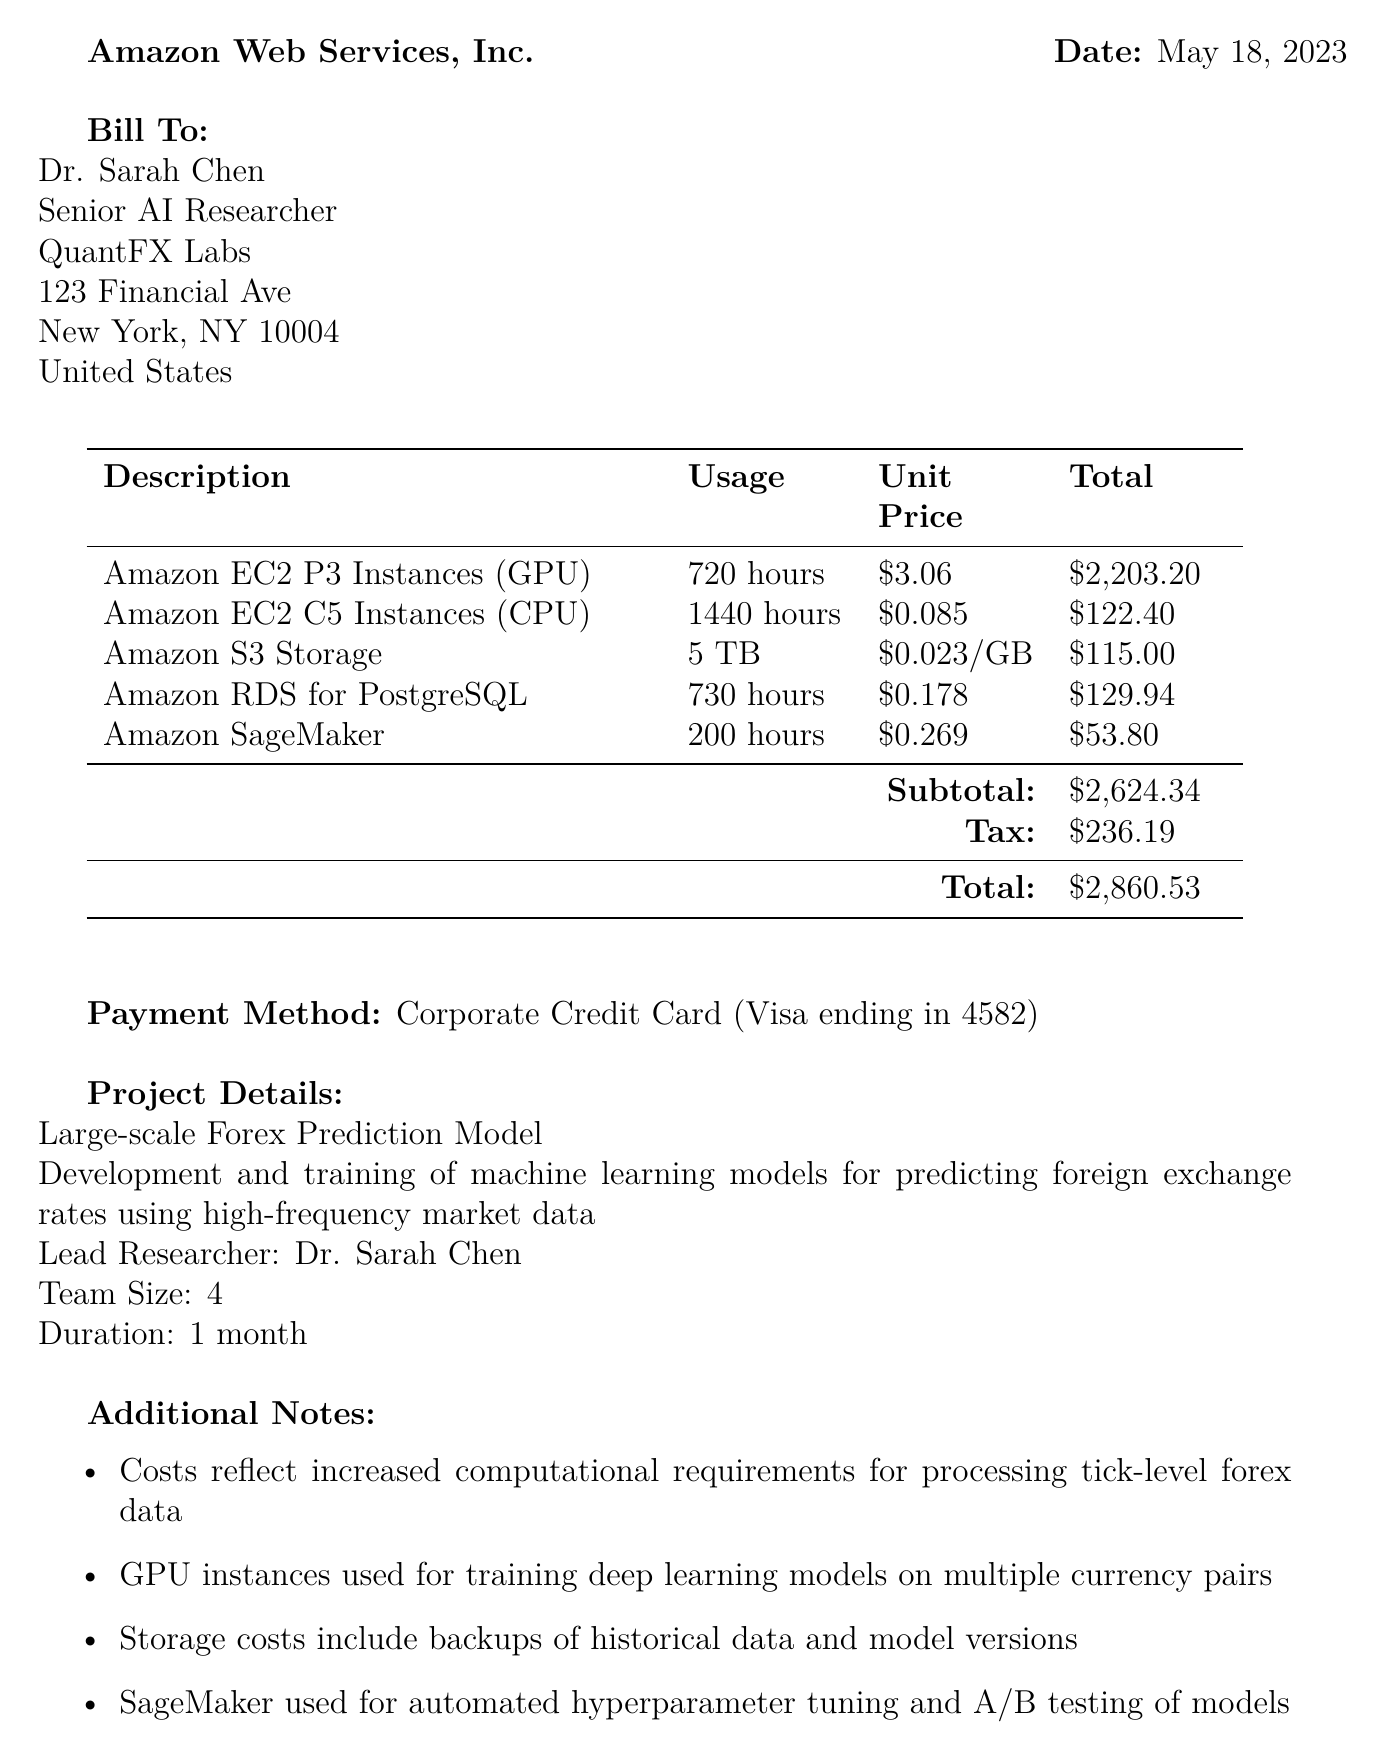what is the receipt number? The receipt number is mentioned at the top of the document and is used to identify the transaction.
Answer: INV-ML20230518-001 who is the lead researcher for the project? The document provides the name of the lead researcher in the project details section.
Answer: Dr. Sarah Chen what is the total amount due? The total amount due is calculated after summing up the subtotal and tax in the financial details of the document.
Answer: $2,860.53 how many hours were used for GPU instances? The usage for GPU instances is specified in the service breakdown of the receipt.
Answer: 720 hours which cloud service was used for storage? The document lists various services used, with a specific mention of the storage solution in the services section.
Answer: Amazon S3 Storage how many team members are involved in the project? The number of team members is directly mentioned in the project details section of the document.
Answer: 4 what is the primary purpose of Amazon SageMaker in this context? The document describes the use of Amazon SageMaker as part of the project details, clarifying its function.
Answer: Managed machine learning platform what is the tax amount charged? The tax amount is explicitly stated in the financial details section of the document as part of the overall charges.
Answer: $236.19 what is the billing address? The billing address is listed in the document under the "Bill To" section, providing details about the recipient.
Answer: 123 Financial Ave, New York, NY 10004, United States 